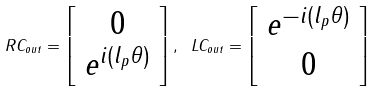<formula> <loc_0><loc_0><loc_500><loc_500>R C _ { o u t } = \left [ \begin{array} { c } 0 \\ e ^ { i ( l _ { p } \theta ) } \end{array} \right ] , \ L C _ { o u t } = \left [ \begin{array} { c } e ^ { - i ( l _ { p } \theta ) } \\ 0 \end{array} \right ]</formula> 